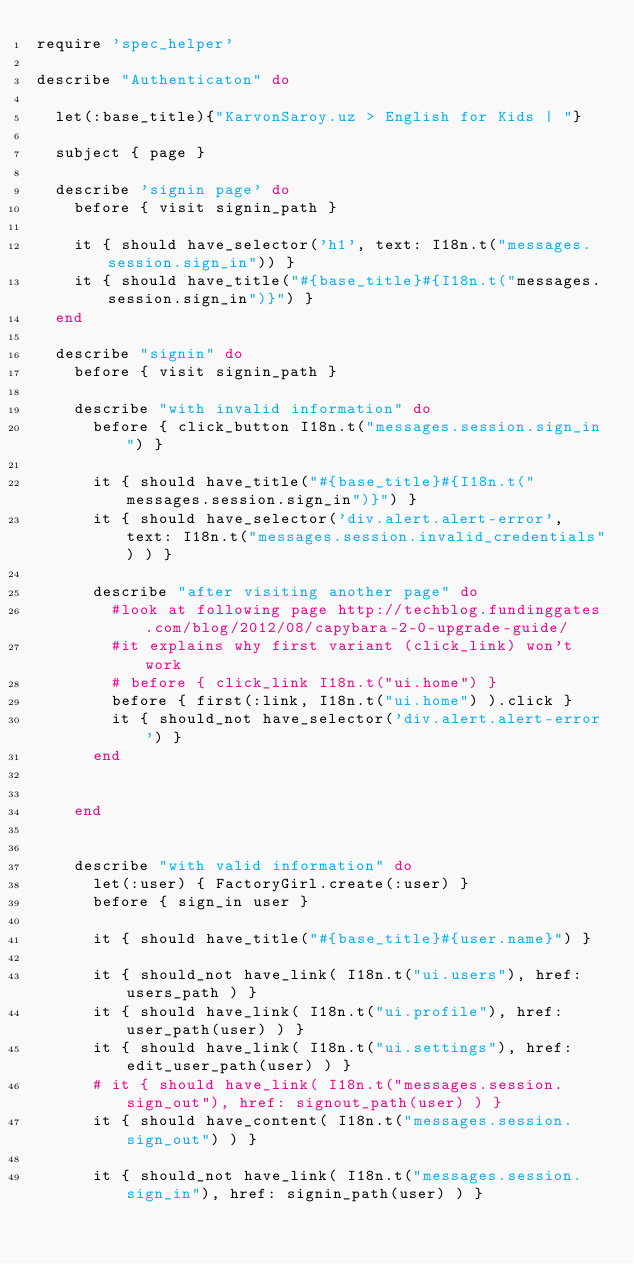<code> <loc_0><loc_0><loc_500><loc_500><_Ruby_>require 'spec_helper'

describe "Authenticaton" do
  
  let(:base_title){"KarvonSaroy.uz > English for Kids | "}
  
  subject { page }

  describe 'signin page' do
    before { visit signin_path }

    it { should have_selector('h1', text: I18n.t("messages.session.sign_in")) }
    it { should have_title("#{base_title}#{I18n.t("messages.session.sign_in")}") }
  end

  describe "signin" do
    before { visit signin_path }
    
    describe "with invalid information" do
      before { click_button I18n.t("messages.session.sign_in") }
      
      it { should have_title("#{base_title}#{I18n.t("messages.session.sign_in")}") }
      it { should have_selector('div.alert.alert-error', text: I18n.t("messages.session.invalid_credentials") ) }
      
      describe "after visiting another page" do
        #look at following page http://techblog.fundinggates.com/blog/2012/08/capybara-2-0-upgrade-guide/
        #it explains why first variant (click_link) won't work
        # before { click_link I18n.t("ui.home") }
        before { first(:link, I18n.t("ui.home") ).click }
        it { should_not have_selector('div.alert.alert-error') }
      end
    

    end


    describe "with valid information" do
      let(:user) { FactoryGirl.create(:user) }
      before { sign_in user }

      it { should have_title("#{base_title}#{user.name}") }

      it { should_not have_link( I18n.t("ui.users"), href: users_path ) }
      it { should have_link( I18n.t("ui.profile"), href: user_path(user) ) }
      it { should have_link( I18n.t("ui.settings"), href: edit_user_path(user) ) }
      # it { should have_link( I18n.t("messages.session.sign_out"), href: signout_path(user) ) }
      it { should have_content( I18n.t("messages.session.sign_out") ) }

      it { should_not have_link( I18n.t("messages.session.sign_in"), href: signin_path(user) ) }
    </code> 